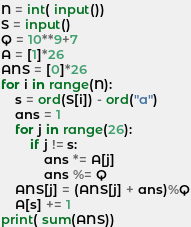<code> <loc_0><loc_0><loc_500><loc_500><_Python_>N = int( input())
S = input()
Q = 10**9+7
A = [1]*26
ANS = [0]*26
for i in range(N):
    s = ord(S[i]) - ord("a")
    ans = 1
    for j in range(26):
        if j != s:
            ans *= A[j]
            ans %= Q
    ANS[j] = (ANS[j] + ans)%Q
    A[s] += 1
print( sum(ANS))
</code> 